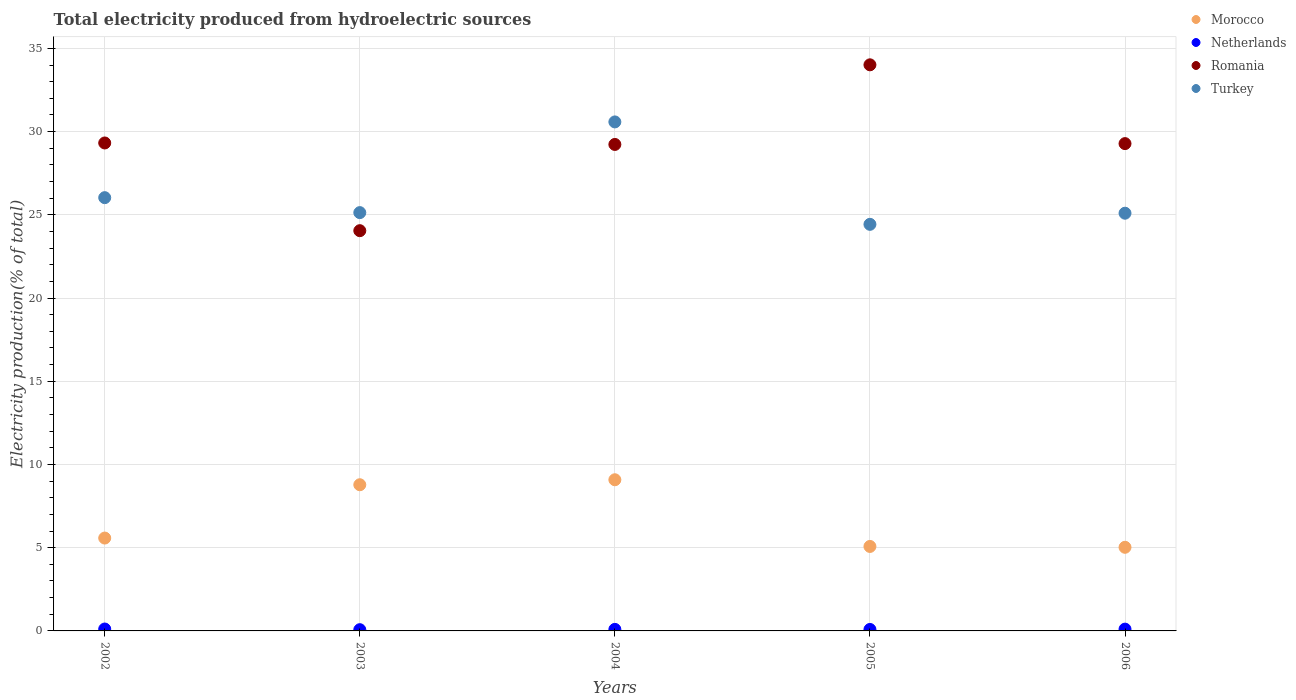Is the number of dotlines equal to the number of legend labels?
Provide a short and direct response. Yes. What is the total electricity produced in Morocco in 2006?
Your answer should be compact. 5.02. Across all years, what is the maximum total electricity produced in Morocco?
Provide a succinct answer. 9.08. Across all years, what is the minimum total electricity produced in Morocco?
Keep it short and to the point. 5.02. In which year was the total electricity produced in Morocco maximum?
Make the answer very short. 2004. What is the total total electricity produced in Turkey in the graph?
Your answer should be very brief. 131.26. What is the difference between the total electricity produced in Turkey in 2002 and that in 2004?
Make the answer very short. -4.55. What is the difference between the total electricity produced in Turkey in 2002 and the total electricity produced in Netherlands in 2005?
Your answer should be very brief. 25.94. What is the average total electricity produced in Romania per year?
Your response must be concise. 29.18. In the year 2006, what is the difference between the total electricity produced in Morocco and total electricity produced in Netherlands?
Keep it short and to the point. 4.92. What is the ratio of the total electricity produced in Romania in 2002 to that in 2003?
Keep it short and to the point. 1.22. Is the total electricity produced in Morocco in 2004 less than that in 2006?
Provide a succinct answer. No. What is the difference between the highest and the second highest total electricity produced in Morocco?
Make the answer very short. 0.3. What is the difference between the highest and the lowest total electricity produced in Netherlands?
Offer a terse response. 0.04. In how many years, is the total electricity produced in Morocco greater than the average total electricity produced in Morocco taken over all years?
Ensure brevity in your answer.  2. Is it the case that in every year, the sum of the total electricity produced in Romania and total electricity produced in Netherlands  is greater than the sum of total electricity produced in Morocco and total electricity produced in Turkey?
Your response must be concise. Yes. Is the total electricity produced in Morocco strictly greater than the total electricity produced in Netherlands over the years?
Provide a short and direct response. Yes. How many dotlines are there?
Make the answer very short. 4. What is the difference between two consecutive major ticks on the Y-axis?
Give a very brief answer. 5. Are the values on the major ticks of Y-axis written in scientific E-notation?
Ensure brevity in your answer.  No. Does the graph contain any zero values?
Keep it short and to the point. No. Does the graph contain grids?
Your response must be concise. Yes. Where does the legend appear in the graph?
Offer a very short reply. Top right. How are the legend labels stacked?
Give a very brief answer. Vertical. What is the title of the graph?
Your answer should be compact. Total electricity produced from hydroelectric sources. What is the label or title of the Y-axis?
Your response must be concise. Electricity production(% of total). What is the Electricity production(% of total) in Morocco in 2002?
Your answer should be very brief. 5.58. What is the Electricity production(% of total) in Netherlands in 2002?
Offer a terse response. 0.11. What is the Electricity production(% of total) of Romania in 2002?
Offer a terse response. 29.32. What is the Electricity production(% of total) in Turkey in 2002?
Offer a terse response. 26.03. What is the Electricity production(% of total) of Morocco in 2003?
Ensure brevity in your answer.  8.78. What is the Electricity production(% of total) in Netherlands in 2003?
Offer a very short reply. 0.07. What is the Electricity production(% of total) of Romania in 2003?
Ensure brevity in your answer.  24.05. What is the Electricity production(% of total) in Turkey in 2003?
Keep it short and to the point. 25.13. What is the Electricity production(% of total) of Morocco in 2004?
Ensure brevity in your answer.  9.08. What is the Electricity production(% of total) of Netherlands in 2004?
Make the answer very short. 0.09. What is the Electricity production(% of total) of Romania in 2004?
Provide a succinct answer. 29.23. What is the Electricity production(% of total) of Turkey in 2004?
Provide a succinct answer. 30.58. What is the Electricity production(% of total) in Morocco in 2005?
Ensure brevity in your answer.  5.08. What is the Electricity production(% of total) in Netherlands in 2005?
Provide a short and direct response. 0.09. What is the Electricity production(% of total) in Romania in 2005?
Make the answer very short. 34.01. What is the Electricity production(% of total) in Turkey in 2005?
Ensure brevity in your answer.  24.43. What is the Electricity production(% of total) of Morocco in 2006?
Offer a terse response. 5.02. What is the Electricity production(% of total) in Netherlands in 2006?
Give a very brief answer. 0.11. What is the Electricity production(% of total) of Romania in 2006?
Your answer should be compact. 29.28. What is the Electricity production(% of total) in Turkey in 2006?
Offer a terse response. 25.1. Across all years, what is the maximum Electricity production(% of total) in Morocco?
Provide a succinct answer. 9.08. Across all years, what is the maximum Electricity production(% of total) of Netherlands?
Provide a short and direct response. 0.11. Across all years, what is the maximum Electricity production(% of total) of Romania?
Provide a succinct answer. 34.01. Across all years, what is the maximum Electricity production(% of total) in Turkey?
Offer a terse response. 30.58. Across all years, what is the minimum Electricity production(% of total) of Morocco?
Offer a terse response. 5.02. Across all years, what is the minimum Electricity production(% of total) of Netherlands?
Your answer should be compact. 0.07. Across all years, what is the minimum Electricity production(% of total) in Romania?
Give a very brief answer. 24.05. Across all years, what is the minimum Electricity production(% of total) in Turkey?
Your response must be concise. 24.43. What is the total Electricity production(% of total) in Morocco in the graph?
Make the answer very short. 33.54. What is the total Electricity production(% of total) of Netherlands in the graph?
Give a very brief answer. 0.48. What is the total Electricity production(% of total) of Romania in the graph?
Offer a very short reply. 145.88. What is the total Electricity production(% of total) in Turkey in the graph?
Your answer should be compact. 131.26. What is the difference between the Electricity production(% of total) of Morocco in 2002 and that in 2003?
Provide a short and direct response. -3.2. What is the difference between the Electricity production(% of total) of Netherlands in 2002 and that in 2003?
Keep it short and to the point. 0.04. What is the difference between the Electricity production(% of total) in Romania in 2002 and that in 2003?
Ensure brevity in your answer.  5.27. What is the difference between the Electricity production(% of total) in Turkey in 2002 and that in 2003?
Offer a terse response. 0.9. What is the difference between the Electricity production(% of total) in Morocco in 2002 and that in 2004?
Make the answer very short. -3.5. What is the difference between the Electricity production(% of total) in Netherlands in 2002 and that in 2004?
Provide a short and direct response. 0.02. What is the difference between the Electricity production(% of total) in Romania in 2002 and that in 2004?
Provide a short and direct response. 0.09. What is the difference between the Electricity production(% of total) in Turkey in 2002 and that in 2004?
Offer a terse response. -4.55. What is the difference between the Electricity production(% of total) in Morocco in 2002 and that in 2005?
Give a very brief answer. 0.5. What is the difference between the Electricity production(% of total) of Netherlands in 2002 and that in 2005?
Make the answer very short. 0.03. What is the difference between the Electricity production(% of total) in Romania in 2002 and that in 2005?
Offer a terse response. -4.7. What is the difference between the Electricity production(% of total) in Turkey in 2002 and that in 2005?
Provide a succinct answer. 1.6. What is the difference between the Electricity production(% of total) of Morocco in 2002 and that in 2006?
Ensure brevity in your answer.  0.56. What is the difference between the Electricity production(% of total) in Netherlands in 2002 and that in 2006?
Provide a succinct answer. 0.01. What is the difference between the Electricity production(% of total) in Romania in 2002 and that in 2006?
Ensure brevity in your answer.  0.04. What is the difference between the Electricity production(% of total) of Turkey in 2002 and that in 2006?
Your answer should be very brief. 0.93. What is the difference between the Electricity production(% of total) in Morocco in 2003 and that in 2004?
Make the answer very short. -0.3. What is the difference between the Electricity production(% of total) in Netherlands in 2003 and that in 2004?
Make the answer very short. -0.02. What is the difference between the Electricity production(% of total) of Romania in 2003 and that in 2004?
Offer a terse response. -5.18. What is the difference between the Electricity production(% of total) of Turkey in 2003 and that in 2004?
Your answer should be compact. -5.45. What is the difference between the Electricity production(% of total) of Morocco in 2003 and that in 2005?
Provide a succinct answer. 3.71. What is the difference between the Electricity production(% of total) in Netherlands in 2003 and that in 2005?
Offer a very short reply. -0.01. What is the difference between the Electricity production(% of total) of Romania in 2003 and that in 2005?
Your answer should be very brief. -9.96. What is the difference between the Electricity production(% of total) of Turkey in 2003 and that in 2005?
Provide a short and direct response. 0.7. What is the difference between the Electricity production(% of total) in Morocco in 2003 and that in 2006?
Give a very brief answer. 3.76. What is the difference between the Electricity production(% of total) of Netherlands in 2003 and that in 2006?
Your response must be concise. -0.03. What is the difference between the Electricity production(% of total) of Romania in 2003 and that in 2006?
Provide a short and direct response. -5.23. What is the difference between the Electricity production(% of total) in Turkey in 2003 and that in 2006?
Ensure brevity in your answer.  0.04. What is the difference between the Electricity production(% of total) of Morocco in 2004 and that in 2005?
Your response must be concise. 4.01. What is the difference between the Electricity production(% of total) in Netherlands in 2004 and that in 2005?
Offer a terse response. 0. What is the difference between the Electricity production(% of total) in Romania in 2004 and that in 2005?
Give a very brief answer. -4.78. What is the difference between the Electricity production(% of total) in Turkey in 2004 and that in 2005?
Your answer should be very brief. 6.15. What is the difference between the Electricity production(% of total) of Morocco in 2004 and that in 2006?
Your response must be concise. 4.06. What is the difference between the Electricity production(% of total) of Netherlands in 2004 and that in 2006?
Give a very brief answer. -0.01. What is the difference between the Electricity production(% of total) in Romania in 2004 and that in 2006?
Keep it short and to the point. -0.05. What is the difference between the Electricity production(% of total) in Turkey in 2004 and that in 2006?
Your response must be concise. 5.48. What is the difference between the Electricity production(% of total) of Morocco in 2005 and that in 2006?
Your answer should be compact. 0.05. What is the difference between the Electricity production(% of total) in Netherlands in 2005 and that in 2006?
Offer a terse response. -0.02. What is the difference between the Electricity production(% of total) in Romania in 2005 and that in 2006?
Your answer should be compact. 4.73. What is the difference between the Electricity production(% of total) in Turkey in 2005 and that in 2006?
Make the answer very short. -0.67. What is the difference between the Electricity production(% of total) of Morocco in 2002 and the Electricity production(% of total) of Netherlands in 2003?
Ensure brevity in your answer.  5.5. What is the difference between the Electricity production(% of total) of Morocco in 2002 and the Electricity production(% of total) of Romania in 2003?
Keep it short and to the point. -18.47. What is the difference between the Electricity production(% of total) of Morocco in 2002 and the Electricity production(% of total) of Turkey in 2003?
Ensure brevity in your answer.  -19.55. What is the difference between the Electricity production(% of total) of Netherlands in 2002 and the Electricity production(% of total) of Romania in 2003?
Keep it short and to the point. -23.93. What is the difference between the Electricity production(% of total) of Netherlands in 2002 and the Electricity production(% of total) of Turkey in 2003?
Provide a succinct answer. -25.02. What is the difference between the Electricity production(% of total) in Romania in 2002 and the Electricity production(% of total) in Turkey in 2003?
Give a very brief answer. 4.18. What is the difference between the Electricity production(% of total) of Morocco in 2002 and the Electricity production(% of total) of Netherlands in 2004?
Offer a very short reply. 5.49. What is the difference between the Electricity production(% of total) of Morocco in 2002 and the Electricity production(% of total) of Romania in 2004?
Keep it short and to the point. -23.65. What is the difference between the Electricity production(% of total) in Morocco in 2002 and the Electricity production(% of total) in Turkey in 2004?
Ensure brevity in your answer.  -25. What is the difference between the Electricity production(% of total) in Netherlands in 2002 and the Electricity production(% of total) in Romania in 2004?
Offer a very short reply. -29.11. What is the difference between the Electricity production(% of total) in Netherlands in 2002 and the Electricity production(% of total) in Turkey in 2004?
Keep it short and to the point. -30.47. What is the difference between the Electricity production(% of total) of Romania in 2002 and the Electricity production(% of total) of Turkey in 2004?
Your response must be concise. -1.26. What is the difference between the Electricity production(% of total) in Morocco in 2002 and the Electricity production(% of total) in Netherlands in 2005?
Your answer should be compact. 5.49. What is the difference between the Electricity production(% of total) in Morocco in 2002 and the Electricity production(% of total) in Romania in 2005?
Make the answer very short. -28.43. What is the difference between the Electricity production(% of total) in Morocco in 2002 and the Electricity production(% of total) in Turkey in 2005?
Give a very brief answer. -18.85. What is the difference between the Electricity production(% of total) in Netherlands in 2002 and the Electricity production(% of total) in Romania in 2005?
Provide a short and direct response. -33.9. What is the difference between the Electricity production(% of total) in Netherlands in 2002 and the Electricity production(% of total) in Turkey in 2005?
Your answer should be compact. -24.31. What is the difference between the Electricity production(% of total) of Romania in 2002 and the Electricity production(% of total) of Turkey in 2005?
Keep it short and to the point. 4.89. What is the difference between the Electricity production(% of total) in Morocco in 2002 and the Electricity production(% of total) in Netherlands in 2006?
Provide a succinct answer. 5.47. What is the difference between the Electricity production(% of total) in Morocco in 2002 and the Electricity production(% of total) in Romania in 2006?
Your answer should be compact. -23.7. What is the difference between the Electricity production(% of total) in Morocco in 2002 and the Electricity production(% of total) in Turkey in 2006?
Ensure brevity in your answer.  -19.52. What is the difference between the Electricity production(% of total) of Netherlands in 2002 and the Electricity production(% of total) of Romania in 2006?
Your answer should be compact. -29.16. What is the difference between the Electricity production(% of total) in Netherlands in 2002 and the Electricity production(% of total) in Turkey in 2006?
Make the answer very short. -24.98. What is the difference between the Electricity production(% of total) of Romania in 2002 and the Electricity production(% of total) of Turkey in 2006?
Give a very brief answer. 4.22. What is the difference between the Electricity production(% of total) in Morocco in 2003 and the Electricity production(% of total) in Netherlands in 2004?
Ensure brevity in your answer.  8.69. What is the difference between the Electricity production(% of total) in Morocco in 2003 and the Electricity production(% of total) in Romania in 2004?
Keep it short and to the point. -20.44. What is the difference between the Electricity production(% of total) of Morocco in 2003 and the Electricity production(% of total) of Turkey in 2004?
Provide a short and direct response. -21.8. What is the difference between the Electricity production(% of total) of Netherlands in 2003 and the Electricity production(% of total) of Romania in 2004?
Give a very brief answer. -29.15. What is the difference between the Electricity production(% of total) in Netherlands in 2003 and the Electricity production(% of total) in Turkey in 2004?
Give a very brief answer. -30.51. What is the difference between the Electricity production(% of total) in Romania in 2003 and the Electricity production(% of total) in Turkey in 2004?
Offer a terse response. -6.53. What is the difference between the Electricity production(% of total) in Morocco in 2003 and the Electricity production(% of total) in Netherlands in 2005?
Provide a succinct answer. 8.69. What is the difference between the Electricity production(% of total) of Morocco in 2003 and the Electricity production(% of total) of Romania in 2005?
Ensure brevity in your answer.  -25.23. What is the difference between the Electricity production(% of total) of Morocco in 2003 and the Electricity production(% of total) of Turkey in 2005?
Give a very brief answer. -15.64. What is the difference between the Electricity production(% of total) in Netherlands in 2003 and the Electricity production(% of total) in Romania in 2005?
Make the answer very short. -33.94. What is the difference between the Electricity production(% of total) of Netherlands in 2003 and the Electricity production(% of total) of Turkey in 2005?
Give a very brief answer. -24.35. What is the difference between the Electricity production(% of total) in Romania in 2003 and the Electricity production(% of total) in Turkey in 2005?
Provide a succinct answer. -0.38. What is the difference between the Electricity production(% of total) of Morocco in 2003 and the Electricity production(% of total) of Netherlands in 2006?
Your answer should be very brief. 8.68. What is the difference between the Electricity production(% of total) in Morocco in 2003 and the Electricity production(% of total) in Romania in 2006?
Your answer should be compact. -20.49. What is the difference between the Electricity production(% of total) of Morocco in 2003 and the Electricity production(% of total) of Turkey in 2006?
Provide a short and direct response. -16.31. What is the difference between the Electricity production(% of total) of Netherlands in 2003 and the Electricity production(% of total) of Romania in 2006?
Offer a very short reply. -29.2. What is the difference between the Electricity production(% of total) in Netherlands in 2003 and the Electricity production(% of total) in Turkey in 2006?
Your response must be concise. -25.02. What is the difference between the Electricity production(% of total) of Romania in 2003 and the Electricity production(% of total) of Turkey in 2006?
Ensure brevity in your answer.  -1.05. What is the difference between the Electricity production(% of total) of Morocco in 2004 and the Electricity production(% of total) of Netherlands in 2005?
Your answer should be very brief. 8.99. What is the difference between the Electricity production(% of total) in Morocco in 2004 and the Electricity production(% of total) in Romania in 2005?
Your answer should be compact. -24.93. What is the difference between the Electricity production(% of total) of Morocco in 2004 and the Electricity production(% of total) of Turkey in 2005?
Ensure brevity in your answer.  -15.34. What is the difference between the Electricity production(% of total) in Netherlands in 2004 and the Electricity production(% of total) in Romania in 2005?
Keep it short and to the point. -33.92. What is the difference between the Electricity production(% of total) in Netherlands in 2004 and the Electricity production(% of total) in Turkey in 2005?
Provide a succinct answer. -24.33. What is the difference between the Electricity production(% of total) of Romania in 2004 and the Electricity production(% of total) of Turkey in 2005?
Make the answer very short. 4.8. What is the difference between the Electricity production(% of total) of Morocco in 2004 and the Electricity production(% of total) of Netherlands in 2006?
Your response must be concise. 8.97. What is the difference between the Electricity production(% of total) of Morocco in 2004 and the Electricity production(% of total) of Romania in 2006?
Make the answer very short. -20.2. What is the difference between the Electricity production(% of total) in Morocco in 2004 and the Electricity production(% of total) in Turkey in 2006?
Give a very brief answer. -16.01. What is the difference between the Electricity production(% of total) of Netherlands in 2004 and the Electricity production(% of total) of Romania in 2006?
Your answer should be very brief. -29.18. What is the difference between the Electricity production(% of total) in Netherlands in 2004 and the Electricity production(% of total) in Turkey in 2006?
Make the answer very short. -25. What is the difference between the Electricity production(% of total) of Romania in 2004 and the Electricity production(% of total) of Turkey in 2006?
Offer a very short reply. 4.13. What is the difference between the Electricity production(% of total) in Morocco in 2005 and the Electricity production(% of total) in Netherlands in 2006?
Offer a very short reply. 4.97. What is the difference between the Electricity production(% of total) of Morocco in 2005 and the Electricity production(% of total) of Romania in 2006?
Offer a very short reply. -24.2. What is the difference between the Electricity production(% of total) of Morocco in 2005 and the Electricity production(% of total) of Turkey in 2006?
Keep it short and to the point. -20.02. What is the difference between the Electricity production(% of total) of Netherlands in 2005 and the Electricity production(% of total) of Romania in 2006?
Give a very brief answer. -29.19. What is the difference between the Electricity production(% of total) of Netherlands in 2005 and the Electricity production(% of total) of Turkey in 2006?
Provide a short and direct response. -25.01. What is the difference between the Electricity production(% of total) of Romania in 2005 and the Electricity production(% of total) of Turkey in 2006?
Provide a succinct answer. 8.92. What is the average Electricity production(% of total) in Morocco per year?
Your answer should be compact. 6.71. What is the average Electricity production(% of total) of Netherlands per year?
Ensure brevity in your answer.  0.1. What is the average Electricity production(% of total) of Romania per year?
Keep it short and to the point. 29.18. What is the average Electricity production(% of total) in Turkey per year?
Keep it short and to the point. 26.25. In the year 2002, what is the difference between the Electricity production(% of total) in Morocco and Electricity production(% of total) in Netherlands?
Offer a terse response. 5.46. In the year 2002, what is the difference between the Electricity production(% of total) in Morocco and Electricity production(% of total) in Romania?
Provide a succinct answer. -23.74. In the year 2002, what is the difference between the Electricity production(% of total) of Morocco and Electricity production(% of total) of Turkey?
Your answer should be very brief. -20.45. In the year 2002, what is the difference between the Electricity production(% of total) in Netherlands and Electricity production(% of total) in Romania?
Offer a terse response. -29.2. In the year 2002, what is the difference between the Electricity production(% of total) in Netherlands and Electricity production(% of total) in Turkey?
Your response must be concise. -25.92. In the year 2002, what is the difference between the Electricity production(% of total) in Romania and Electricity production(% of total) in Turkey?
Offer a very short reply. 3.29. In the year 2003, what is the difference between the Electricity production(% of total) in Morocco and Electricity production(% of total) in Netherlands?
Keep it short and to the point. 8.71. In the year 2003, what is the difference between the Electricity production(% of total) in Morocco and Electricity production(% of total) in Romania?
Keep it short and to the point. -15.26. In the year 2003, what is the difference between the Electricity production(% of total) in Morocco and Electricity production(% of total) in Turkey?
Your response must be concise. -16.35. In the year 2003, what is the difference between the Electricity production(% of total) of Netherlands and Electricity production(% of total) of Romania?
Keep it short and to the point. -23.97. In the year 2003, what is the difference between the Electricity production(% of total) in Netherlands and Electricity production(% of total) in Turkey?
Provide a short and direct response. -25.06. In the year 2003, what is the difference between the Electricity production(% of total) of Romania and Electricity production(% of total) of Turkey?
Keep it short and to the point. -1.09. In the year 2004, what is the difference between the Electricity production(% of total) in Morocco and Electricity production(% of total) in Netherlands?
Provide a short and direct response. 8.99. In the year 2004, what is the difference between the Electricity production(% of total) of Morocco and Electricity production(% of total) of Romania?
Ensure brevity in your answer.  -20.14. In the year 2004, what is the difference between the Electricity production(% of total) in Morocco and Electricity production(% of total) in Turkey?
Give a very brief answer. -21.5. In the year 2004, what is the difference between the Electricity production(% of total) in Netherlands and Electricity production(% of total) in Romania?
Offer a terse response. -29.13. In the year 2004, what is the difference between the Electricity production(% of total) in Netherlands and Electricity production(% of total) in Turkey?
Offer a very short reply. -30.49. In the year 2004, what is the difference between the Electricity production(% of total) in Romania and Electricity production(% of total) in Turkey?
Your response must be concise. -1.35. In the year 2005, what is the difference between the Electricity production(% of total) in Morocco and Electricity production(% of total) in Netherlands?
Provide a succinct answer. 4.99. In the year 2005, what is the difference between the Electricity production(% of total) of Morocco and Electricity production(% of total) of Romania?
Offer a terse response. -28.94. In the year 2005, what is the difference between the Electricity production(% of total) in Morocco and Electricity production(% of total) in Turkey?
Give a very brief answer. -19.35. In the year 2005, what is the difference between the Electricity production(% of total) of Netherlands and Electricity production(% of total) of Romania?
Ensure brevity in your answer.  -33.92. In the year 2005, what is the difference between the Electricity production(% of total) in Netherlands and Electricity production(% of total) in Turkey?
Make the answer very short. -24.34. In the year 2005, what is the difference between the Electricity production(% of total) of Romania and Electricity production(% of total) of Turkey?
Offer a very short reply. 9.58. In the year 2006, what is the difference between the Electricity production(% of total) in Morocco and Electricity production(% of total) in Netherlands?
Your response must be concise. 4.92. In the year 2006, what is the difference between the Electricity production(% of total) in Morocco and Electricity production(% of total) in Romania?
Your answer should be compact. -24.25. In the year 2006, what is the difference between the Electricity production(% of total) in Morocco and Electricity production(% of total) in Turkey?
Make the answer very short. -20.07. In the year 2006, what is the difference between the Electricity production(% of total) in Netherlands and Electricity production(% of total) in Romania?
Give a very brief answer. -29.17. In the year 2006, what is the difference between the Electricity production(% of total) in Netherlands and Electricity production(% of total) in Turkey?
Give a very brief answer. -24.99. In the year 2006, what is the difference between the Electricity production(% of total) in Romania and Electricity production(% of total) in Turkey?
Provide a succinct answer. 4.18. What is the ratio of the Electricity production(% of total) of Morocco in 2002 to that in 2003?
Ensure brevity in your answer.  0.64. What is the ratio of the Electricity production(% of total) in Netherlands in 2002 to that in 2003?
Your answer should be very brief. 1.54. What is the ratio of the Electricity production(% of total) in Romania in 2002 to that in 2003?
Keep it short and to the point. 1.22. What is the ratio of the Electricity production(% of total) of Turkey in 2002 to that in 2003?
Your answer should be very brief. 1.04. What is the ratio of the Electricity production(% of total) of Morocco in 2002 to that in 2004?
Offer a terse response. 0.61. What is the ratio of the Electricity production(% of total) of Netherlands in 2002 to that in 2004?
Your response must be concise. 1.24. What is the ratio of the Electricity production(% of total) in Turkey in 2002 to that in 2004?
Give a very brief answer. 0.85. What is the ratio of the Electricity production(% of total) in Morocco in 2002 to that in 2005?
Provide a short and direct response. 1.1. What is the ratio of the Electricity production(% of total) of Netherlands in 2002 to that in 2005?
Your response must be concise. 1.31. What is the ratio of the Electricity production(% of total) in Romania in 2002 to that in 2005?
Offer a very short reply. 0.86. What is the ratio of the Electricity production(% of total) in Turkey in 2002 to that in 2005?
Make the answer very short. 1.07. What is the ratio of the Electricity production(% of total) in Morocco in 2002 to that in 2006?
Offer a very short reply. 1.11. What is the ratio of the Electricity production(% of total) of Netherlands in 2002 to that in 2006?
Make the answer very short. 1.06. What is the ratio of the Electricity production(% of total) in Turkey in 2002 to that in 2006?
Offer a terse response. 1.04. What is the ratio of the Electricity production(% of total) in Netherlands in 2003 to that in 2004?
Your answer should be very brief. 0.8. What is the ratio of the Electricity production(% of total) in Romania in 2003 to that in 2004?
Your answer should be very brief. 0.82. What is the ratio of the Electricity production(% of total) of Turkey in 2003 to that in 2004?
Give a very brief answer. 0.82. What is the ratio of the Electricity production(% of total) of Morocco in 2003 to that in 2005?
Your answer should be very brief. 1.73. What is the ratio of the Electricity production(% of total) in Netherlands in 2003 to that in 2005?
Your answer should be very brief. 0.85. What is the ratio of the Electricity production(% of total) in Romania in 2003 to that in 2005?
Your answer should be very brief. 0.71. What is the ratio of the Electricity production(% of total) in Turkey in 2003 to that in 2005?
Offer a very short reply. 1.03. What is the ratio of the Electricity production(% of total) of Morocco in 2003 to that in 2006?
Ensure brevity in your answer.  1.75. What is the ratio of the Electricity production(% of total) in Netherlands in 2003 to that in 2006?
Make the answer very short. 0.69. What is the ratio of the Electricity production(% of total) in Romania in 2003 to that in 2006?
Your answer should be very brief. 0.82. What is the ratio of the Electricity production(% of total) of Morocco in 2004 to that in 2005?
Give a very brief answer. 1.79. What is the ratio of the Electricity production(% of total) in Netherlands in 2004 to that in 2005?
Make the answer very short. 1.06. What is the ratio of the Electricity production(% of total) in Romania in 2004 to that in 2005?
Provide a succinct answer. 0.86. What is the ratio of the Electricity production(% of total) of Turkey in 2004 to that in 2005?
Give a very brief answer. 1.25. What is the ratio of the Electricity production(% of total) of Morocco in 2004 to that in 2006?
Provide a short and direct response. 1.81. What is the ratio of the Electricity production(% of total) of Netherlands in 2004 to that in 2006?
Your response must be concise. 0.86. What is the ratio of the Electricity production(% of total) of Romania in 2004 to that in 2006?
Offer a terse response. 1. What is the ratio of the Electricity production(% of total) of Turkey in 2004 to that in 2006?
Give a very brief answer. 1.22. What is the ratio of the Electricity production(% of total) in Morocco in 2005 to that in 2006?
Provide a short and direct response. 1.01. What is the ratio of the Electricity production(% of total) of Netherlands in 2005 to that in 2006?
Ensure brevity in your answer.  0.82. What is the ratio of the Electricity production(% of total) in Romania in 2005 to that in 2006?
Your answer should be very brief. 1.16. What is the ratio of the Electricity production(% of total) of Turkey in 2005 to that in 2006?
Make the answer very short. 0.97. What is the difference between the highest and the second highest Electricity production(% of total) in Morocco?
Keep it short and to the point. 0.3. What is the difference between the highest and the second highest Electricity production(% of total) in Netherlands?
Provide a short and direct response. 0.01. What is the difference between the highest and the second highest Electricity production(% of total) of Romania?
Your answer should be compact. 4.7. What is the difference between the highest and the second highest Electricity production(% of total) in Turkey?
Keep it short and to the point. 4.55. What is the difference between the highest and the lowest Electricity production(% of total) of Morocco?
Ensure brevity in your answer.  4.06. What is the difference between the highest and the lowest Electricity production(% of total) in Netherlands?
Offer a terse response. 0.04. What is the difference between the highest and the lowest Electricity production(% of total) in Romania?
Offer a terse response. 9.96. What is the difference between the highest and the lowest Electricity production(% of total) of Turkey?
Offer a very short reply. 6.15. 